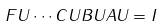Convert formula to latex. <formula><loc_0><loc_0><loc_500><loc_500>F U \cdots C U B U A U = I</formula> 